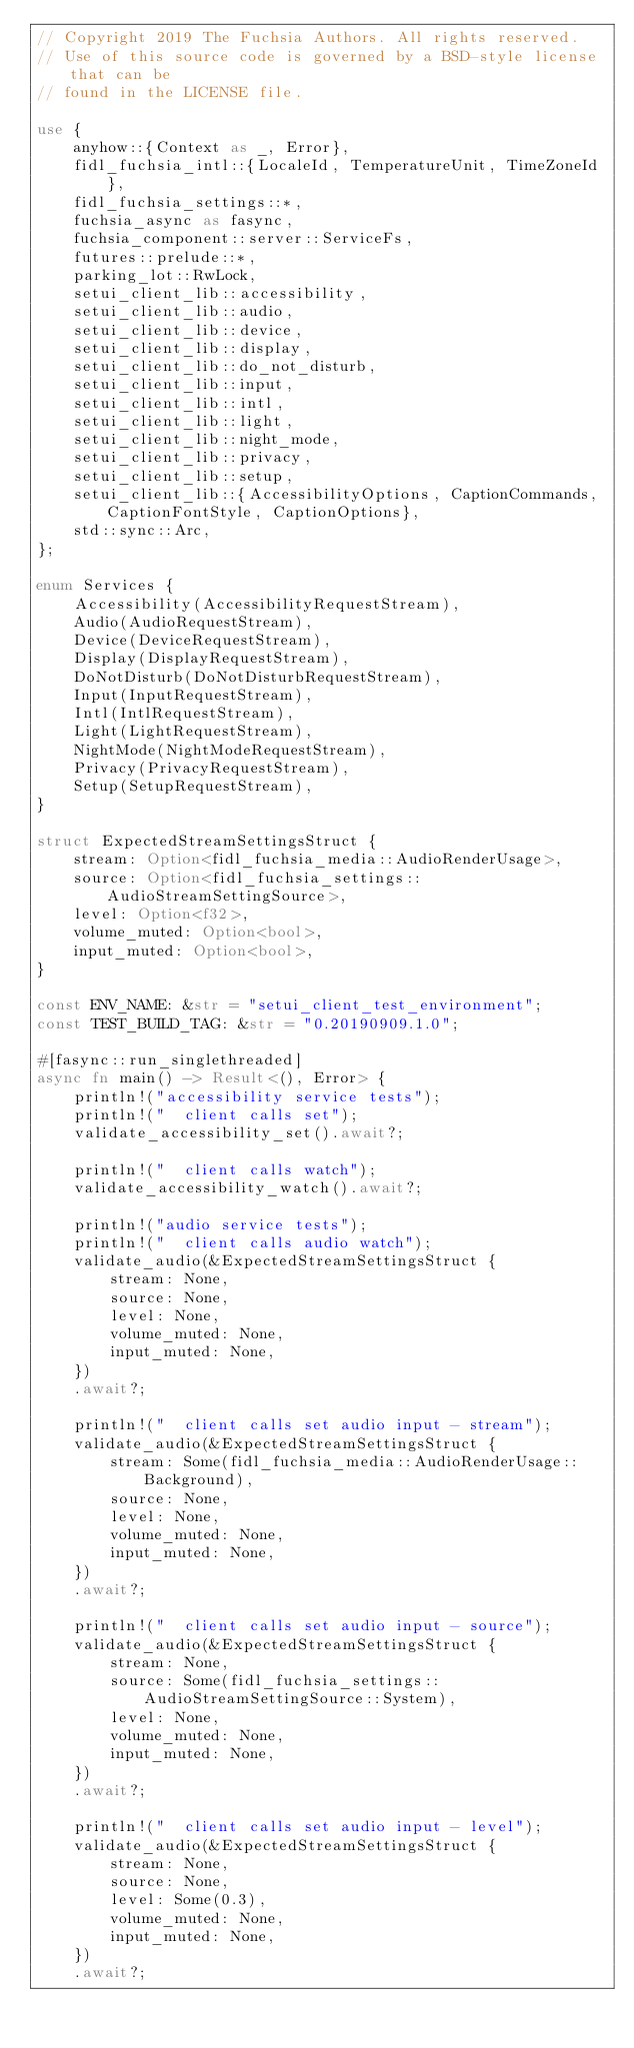Convert code to text. <code><loc_0><loc_0><loc_500><loc_500><_Rust_>// Copyright 2019 The Fuchsia Authors. All rights reserved.
// Use of this source code is governed by a BSD-style license that can be
// found in the LICENSE file.

use {
    anyhow::{Context as _, Error},
    fidl_fuchsia_intl::{LocaleId, TemperatureUnit, TimeZoneId},
    fidl_fuchsia_settings::*,
    fuchsia_async as fasync,
    fuchsia_component::server::ServiceFs,
    futures::prelude::*,
    parking_lot::RwLock,
    setui_client_lib::accessibility,
    setui_client_lib::audio,
    setui_client_lib::device,
    setui_client_lib::display,
    setui_client_lib::do_not_disturb,
    setui_client_lib::input,
    setui_client_lib::intl,
    setui_client_lib::light,
    setui_client_lib::night_mode,
    setui_client_lib::privacy,
    setui_client_lib::setup,
    setui_client_lib::{AccessibilityOptions, CaptionCommands, CaptionFontStyle, CaptionOptions},
    std::sync::Arc,
};

enum Services {
    Accessibility(AccessibilityRequestStream),
    Audio(AudioRequestStream),
    Device(DeviceRequestStream),
    Display(DisplayRequestStream),
    DoNotDisturb(DoNotDisturbRequestStream),
    Input(InputRequestStream),
    Intl(IntlRequestStream),
    Light(LightRequestStream),
    NightMode(NightModeRequestStream),
    Privacy(PrivacyRequestStream),
    Setup(SetupRequestStream),
}

struct ExpectedStreamSettingsStruct {
    stream: Option<fidl_fuchsia_media::AudioRenderUsage>,
    source: Option<fidl_fuchsia_settings::AudioStreamSettingSource>,
    level: Option<f32>,
    volume_muted: Option<bool>,
    input_muted: Option<bool>,
}

const ENV_NAME: &str = "setui_client_test_environment";
const TEST_BUILD_TAG: &str = "0.20190909.1.0";

#[fasync::run_singlethreaded]
async fn main() -> Result<(), Error> {
    println!("accessibility service tests");
    println!("  client calls set");
    validate_accessibility_set().await?;

    println!("  client calls watch");
    validate_accessibility_watch().await?;

    println!("audio service tests");
    println!("  client calls audio watch");
    validate_audio(&ExpectedStreamSettingsStruct {
        stream: None,
        source: None,
        level: None,
        volume_muted: None,
        input_muted: None,
    })
    .await?;

    println!("  client calls set audio input - stream");
    validate_audio(&ExpectedStreamSettingsStruct {
        stream: Some(fidl_fuchsia_media::AudioRenderUsage::Background),
        source: None,
        level: None,
        volume_muted: None,
        input_muted: None,
    })
    .await?;

    println!("  client calls set audio input - source");
    validate_audio(&ExpectedStreamSettingsStruct {
        stream: None,
        source: Some(fidl_fuchsia_settings::AudioStreamSettingSource::System),
        level: None,
        volume_muted: None,
        input_muted: None,
    })
    .await?;

    println!("  client calls set audio input - level");
    validate_audio(&ExpectedStreamSettingsStruct {
        stream: None,
        source: None,
        level: Some(0.3),
        volume_muted: None,
        input_muted: None,
    })
    .await?;
</code> 